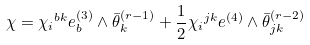<formula> <loc_0><loc_0><loc_500><loc_500>\chi = \chi { _ { i } } ^ { b k } e _ { b } ^ { ( 3 ) } \wedge \bar { \theta } ^ { ( r - 1 ) } _ { k } + \frac { 1 } { 2 } \chi { _ { i } } ^ { j k } e ^ { ( 4 ) } \wedge \bar { \theta } ^ { ( r - 2 ) } _ { j k }</formula> 